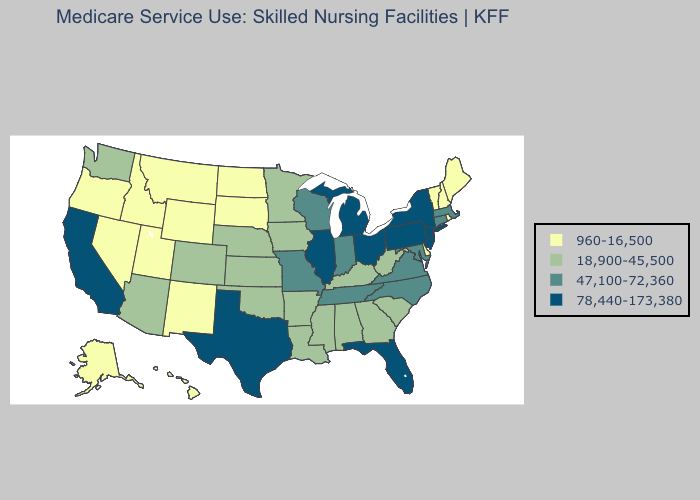What is the lowest value in the USA?
Answer briefly. 960-16,500. Name the states that have a value in the range 78,440-173,380?
Give a very brief answer. California, Florida, Illinois, Michigan, New Jersey, New York, Ohio, Pennsylvania, Texas. Does the map have missing data?
Give a very brief answer. No. Does the first symbol in the legend represent the smallest category?
Short answer required. Yes. Does Massachusetts have the highest value in the USA?
Be succinct. No. What is the lowest value in the Northeast?
Write a very short answer. 960-16,500. Does Maine have the highest value in the Northeast?
Keep it brief. No. Does Texas have the highest value in the USA?
Give a very brief answer. Yes. Does California have the highest value in the West?
Quick response, please. Yes. Name the states that have a value in the range 960-16,500?
Give a very brief answer. Alaska, Delaware, Hawaii, Idaho, Maine, Montana, Nevada, New Hampshire, New Mexico, North Dakota, Oregon, Rhode Island, South Dakota, Utah, Vermont, Wyoming. Does Arizona have the highest value in the West?
Short answer required. No. Is the legend a continuous bar?
Keep it brief. No. Is the legend a continuous bar?
Concise answer only. No. Name the states that have a value in the range 78,440-173,380?
Keep it brief. California, Florida, Illinois, Michigan, New Jersey, New York, Ohio, Pennsylvania, Texas. What is the lowest value in the South?
Answer briefly. 960-16,500. 